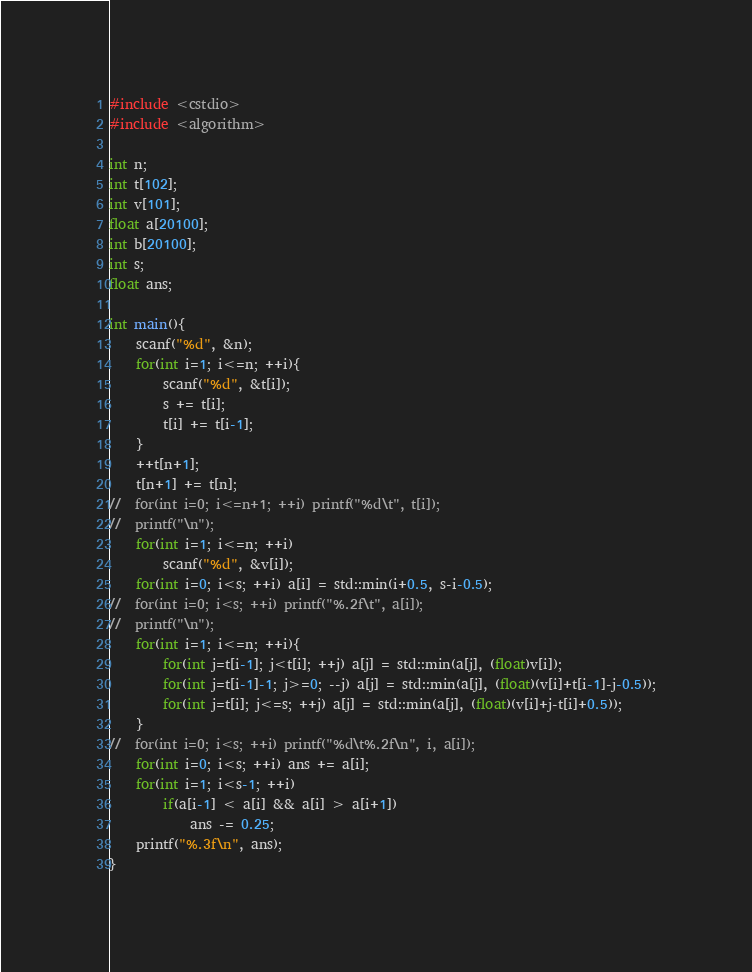<code> <loc_0><loc_0><loc_500><loc_500><_C++_>#include <cstdio>
#include <algorithm>

int n;
int t[102];
int v[101];
float a[20100];
int b[20100];
int s;
float ans;

int main(){
	scanf("%d", &n);
	for(int i=1; i<=n; ++i){
		scanf("%d", &t[i]);
		s += t[i];
		t[i] += t[i-1];
	}
	++t[n+1];
	t[n+1] += t[n];
//	for(int i=0; i<=n+1; ++i) printf("%d\t", t[i]);
//	printf("\n");
	for(int i=1; i<=n; ++i)
		scanf("%d", &v[i]);
	for(int i=0; i<s; ++i) a[i] = std::min(i+0.5, s-i-0.5);
//	for(int i=0; i<s; ++i) printf("%.2f\t", a[i]);
//	printf("\n");
	for(int i=1; i<=n; ++i){
		for(int j=t[i-1]; j<t[i]; ++j) a[j] = std::min(a[j], (float)v[i]);
		for(int j=t[i-1]-1; j>=0; --j) a[j] = std::min(a[j], (float)(v[i]+t[i-1]-j-0.5));
		for(int j=t[i]; j<=s; ++j) a[j] = std::min(a[j], (float)(v[i]+j-t[i]+0.5));
	}
//	for(int i=0; i<s; ++i) printf("%d\t%.2f\n", i, a[i]);
	for(int i=0; i<s; ++i) ans += a[i];
	for(int i=1; i<s-1; ++i)
		if(a[i-1] < a[i] && a[i] > a[i+1])
			ans -= 0.25;
	printf("%.3f\n", ans);
}</code> 